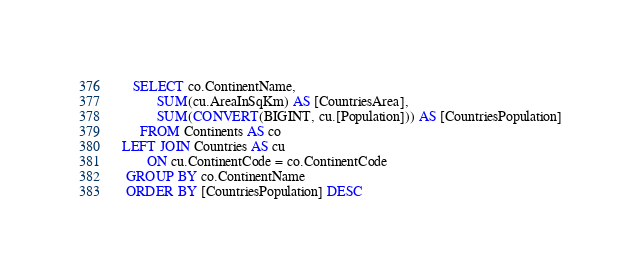Convert code to text. <code><loc_0><loc_0><loc_500><loc_500><_SQL_>   SELECT co.ContinentName,
		  SUM(cu.AreaInSqKm) AS [CountriesArea],
		  SUM(CONVERT(BIGINT, cu.[Population])) AS [CountriesPopulation]
     FROM Continents AS co
LEFT JOIN Countries AS cu
       ON cu.ContinentCode = co.ContinentCode
 GROUP BY co.ContinentName
 ORDER BY [CountriesPopulation] DESC</code> 